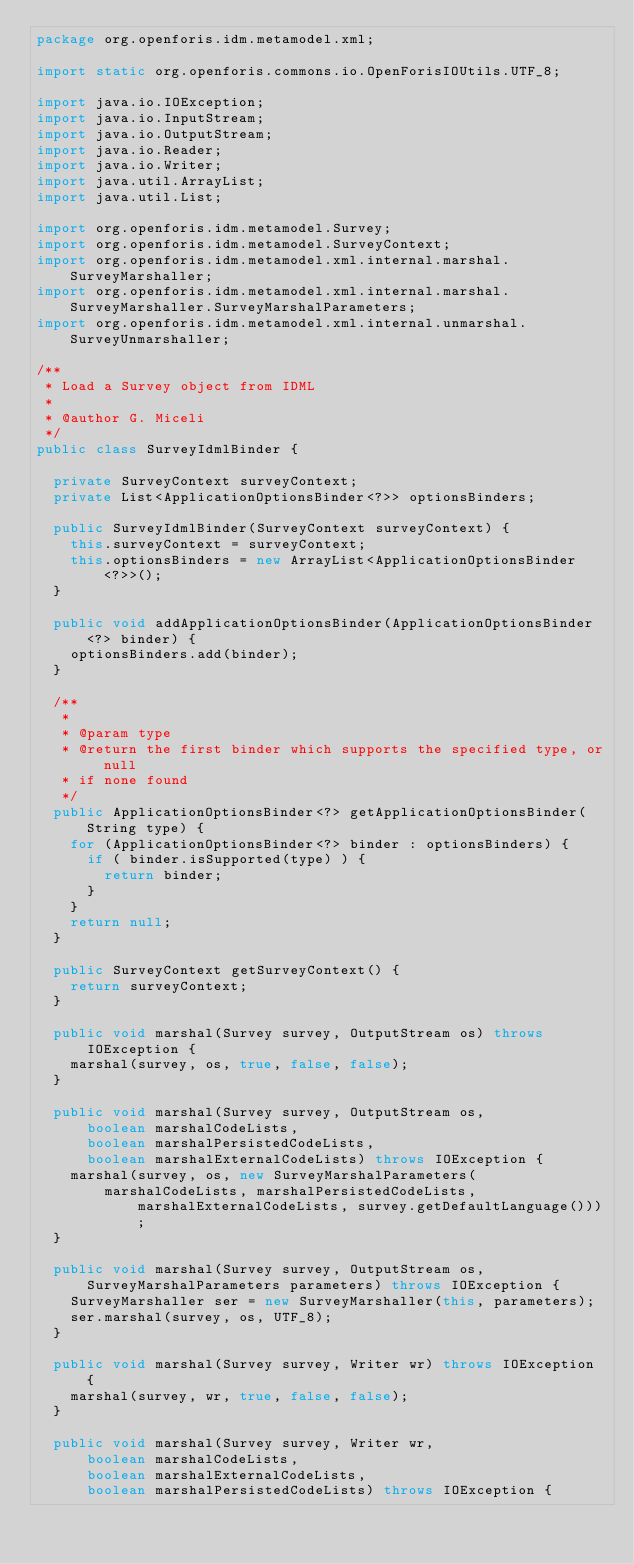Convert code to text. <code><loc_0><loc_0><loc_500><loc_500><_Java_>package org.openforis.idm.metamodel.xml;

import static org.openforis.commons.io.OpenForisIOUtils.UTF_8;

import java.io.IOException;
import java.io.InputStream;
import java.io.OutputStream;
import java.io.Reader;
import java.io.Writer;
import java.util.ArrayList;
import java.util.List;

import org.openforis.idm.metamodel.Survey;
import org.openforis.idm.metamodel.SurveyContext;
import org.openforis.idm.metamodel.xml.internal.marshal.SurveyMarshaller;
import org.openforis.idm.metamodel.xml.internal.marshal.SurveyMarshaller.SurveyMarshalParameters;
import org.openforis.idm.metamodel.xml.internal.unmarshal.SurveyUnmarshaller;

/**
 * Load a Survey object from IDML
 * 
 * @author G. Miceli
 */
public class SurveyIdmlBinder {
	
	private SurveyContext surveyContext;
	private List<ApplicationOptionsBinder<?>> optionsBinders;

	public SurveyIdmlBinder(SurveyContext surveyContext) {
		this.surveyContext = surveyContext;
		this.optionsBinders = new ArrayList<ApplicationOptionsBinder<?>>();
	}

	public void addApplicationOptionsBinder(ApplicationOptionsBinder<?> binder) {
		optionsBinders.add(binder);
	}

	/**
	 * 
	 * @param type
	 * @return the first binder which supports the specified type, or null
	 * if none found
	 */
	public ApplicationOptionsBinder<?> getApplicationOptionsBinder(String type) {
		for (ApplicationOptionsBinder<?> binder : optionsBinders) {
			if ( binder.isSupported(type) ) {
				return binder;
			}
		}
		return null;
	}
	
	public SurveyContext getSurveyContext() {
		return surveyContext;
	}
	
	public void marshal(Survey survey, OutputStream os) throws IOException {
		marshal(survey, os, true, false, false);
	}
	
	public void marshal(Survey survey, OutputStream os,
			boolean marshalCodeLists, 
			boolean marshalPersistedCodeLists,
			boolean marshalExternalCodeLists) throws IOException {
		marshal(survey, os, new SurveyMarshalParameters(
				marshalCodeLists, marshalPersistedCodeLists, marshalExternalCodeLists, survey.getDefaultLanguage()));
	}
	
	public void marshal(Survey survey, OutputStream os, SurveyMarshalParameters parameters) throws IOException {
		SurveyMarshaller ser = new SurveyMarshaller(this, parameters); 
		ser.marshal(survey, os, UTF_8);
	}

	public void marshal(Survey survey, Writer wr) throws IOException {
		marshal(survey, wr, true, false, false);
	}

	public void marshal(Survey survey, Writer wr,
			boolean marshalCodeLists, 
			boolean marshalExternalCodeLists,
			boolean marshalPersistedCodeLists) throws IOException {</code> 